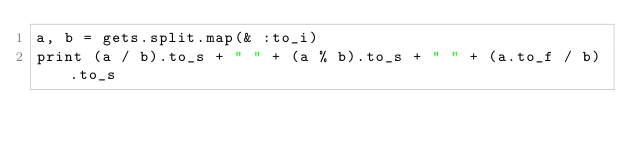Convert code to text. <code><loc_0><loc_0><loc_500><loc_500><_Ruby_>a, b = gets.split.map(& :to_i)
print (a / b).to_s + " " + (a % b).to_s + " " + (a.to_f / b).to_s</code> 